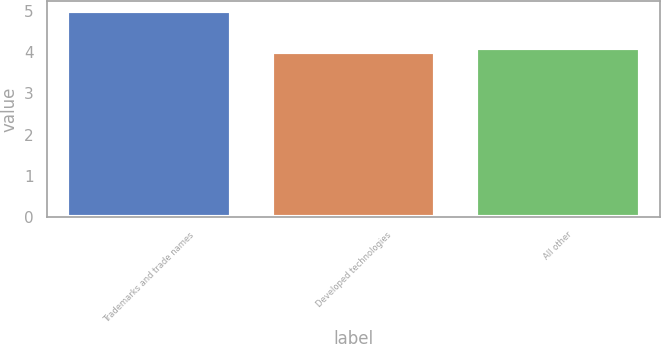Convert chart. <chart><loc_0><loc_0><loc_500><loc_500><bar_chart><fcel>Trademarks and trade names<fcel>Developed technologies<fcel>All other<nl><fcel>5<fcel>4<fcel>4.1<nl></chart> 